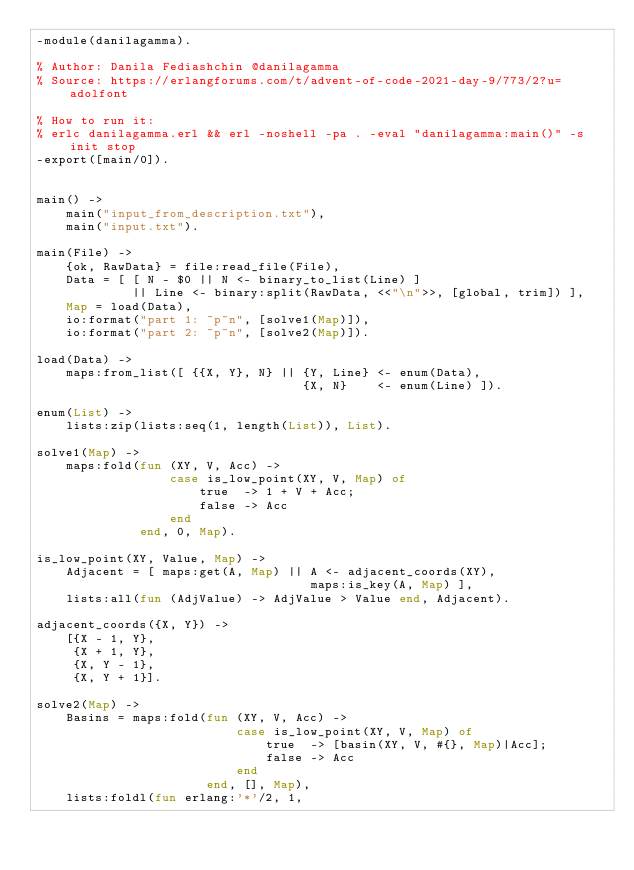<code> <loc_0><loc_0><loc_500><loc_500><_Erlang_>-module(danilagamma).

% Author: Danila Fediashchin @danilagamma
% Source: https://erlangforums.com/t/advent-of-code-2021-day-9/773/2?u=adolfont

% How to run it:
% erlc danilagamma.erl && erl -noshell -pa . -eval "danilagamma:main()" -s init stop
-export([main/0]).


main() ->
    main("input_from_description.txt"),
    main("input.txt").

main(File) ->
    {ok, RawData} = file:read_file(File),
    Data = [ [ N - $0 || N <- binary_to_list(Line) ]
             || Line <- binary:split(RawData, <<"\n">>, [global, trim]) ],
    Map = load(Data),
    io:format("part 1: ~p~n", [solve1(Map)]),
    io:format("part 2: ~p~n", [solve2(Map)]).

load(Data) ->
    maps:from_list([ {{X, Y}, N} || {Y, Line} <- enum(Data),
                                    {X, N}    <- enum(Line) ]).

enum(List) ->
    lists:zip(lists:seq(1, length(List)), List).

solve1(Map) ->
    maps:fold(fun (XY, V, Acc) ->
                  case is_low_point(XY, V, Map) of
                      true  -> 1 + V + Acc;
                      false -> Acc
                  end
              end, 0, Map).

is_low_point(XY, Value, Map) ->
    Adjacent = [ maps:get(A, Map) || A <- adjacent_coords(XY),
                                     maps:is_key(A, Map) ],
    lists:all(fun (AdjValue) -> AdjValue > Value end, Adjacent).

adjacent_coords({X, Y}) ->
    [{X - 1, Y},
     {X + 1, Y},
     {X, Y - 1},
     {X, Y + 1}].

solve2(Map) ->
    Basins = maps:fold(fun (XY, V, Acc) ->
                           case is_low_point(XY, V, Map) of
                               true  -> [basin(XY, V, #{}, Map)|Acc];
                               false -> Acc
                           end
                       end, [], Map),
    lists:foldl(fun erlang:'*'/2, 1,</code> 